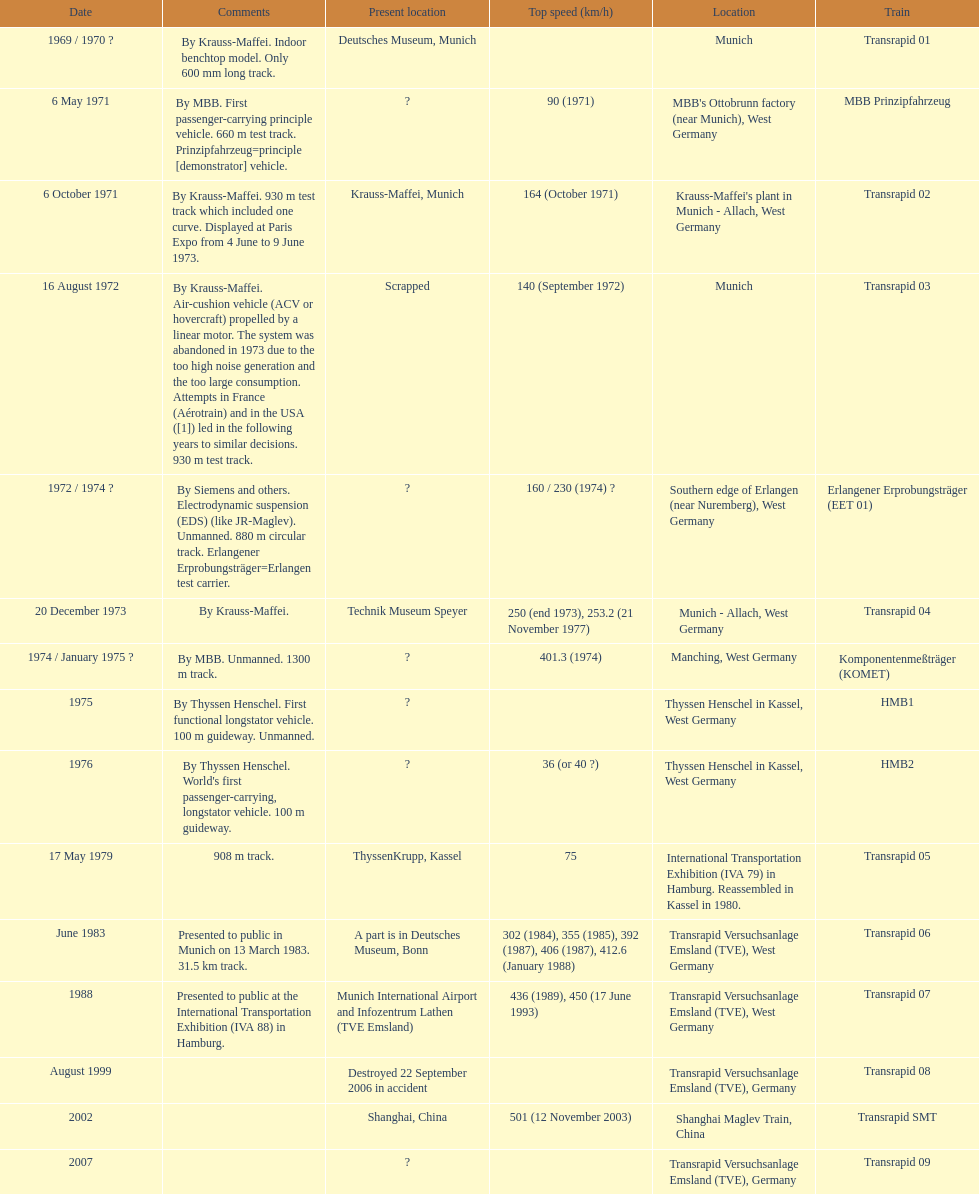What is the only train to reach a top speed of 500 or more? Transrapid SMT. 